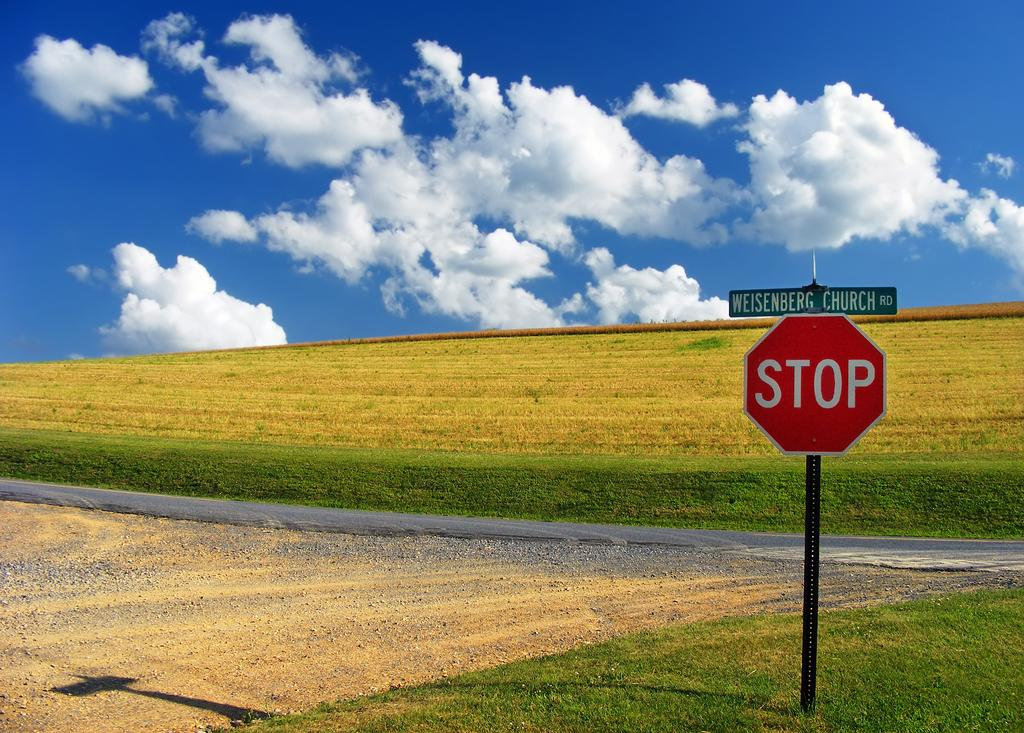<image>
Provide a brief description of the given image. An open field with a blue sky and a stop sign on Church road. 